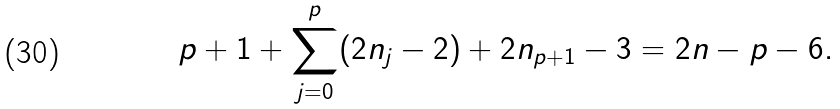Convert formula to latex. <formula><loc_0><loc_0><loc_500><loc_500>p + 1 + \sum ^ { p } _ { j = 0 } ( 2 n _ { j } - 2 ) + 2 n _ { p + 1 } - 3 = 2 n - p - 6 .</formula> 